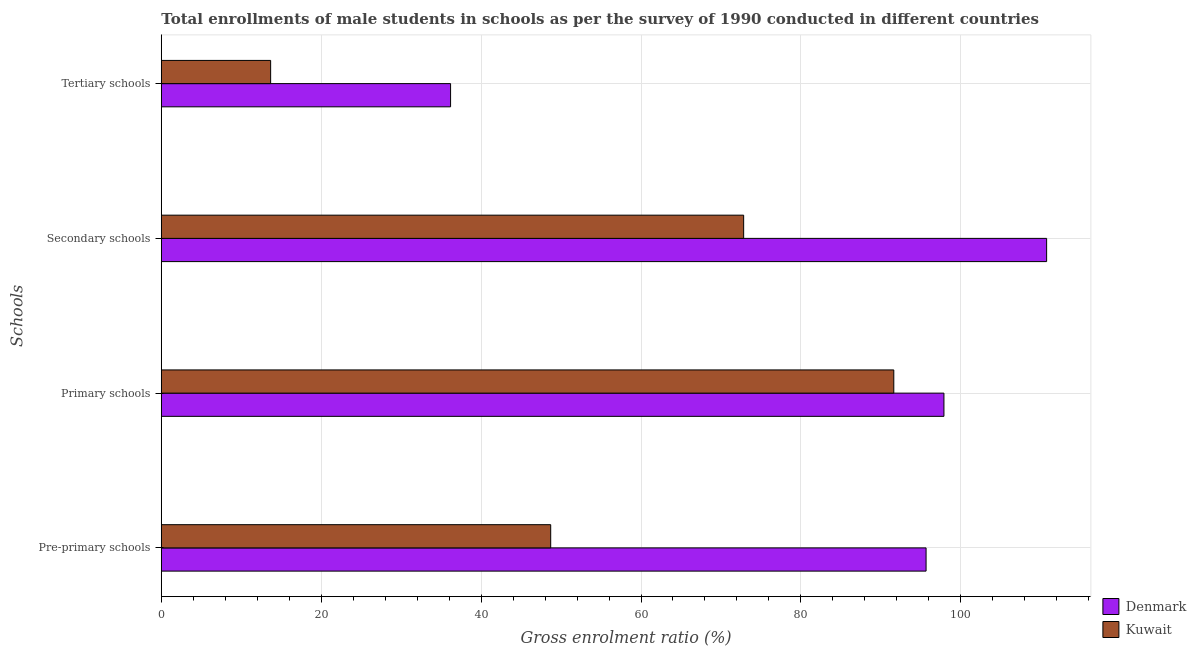How many groups of bars are there?
Give a very brief answer. 4. Are the number of bars per tick equal to the number of legend labels?
Your response must be concise. Yes. How many bars are there on the 2nd tick from the top?
Provide a short and direct response. 2. How many bars are there on the 1st tick from the bottom?
Ensure brevity in your answer.  2. What is the label of the 4th group of bars from the top?
Keep it short and to the point. Pre-primary schools. What is the gross enrolment ratio(male) in pre-primary schools in Kuwait?
Provide a succinct answer. 48.71. Across all countries, what is the maximum gross enrolment ratio(male) in pre-primary schools?
Your answer should be compact. 95.66. Across all countries, what is the minimum gross enrolment ratio(male) in tertiary schools?
Give a very brief answer. 13.67. In which country was the gross enrolment ratio(male) in secondary schools maximum?
Offer a terse response. Denmark. In which country was the gross enrolment ratio(male) in primary schools minimum?
Your answer should be compact. Kuwait. What is the total gross enrolment ratio(male) in primary schools in the graph?
Your answer should be very brief. 189.51. What is the difference between the gross enrolment ratio(male) in secondary schools in Denmark and that in Kuwait?
Offer a very short reply. 37.9. What is the difference between the gross enrolment ratio(male) in pre-primary schools in Denmark and the gross enrolment ratio(male) in secondary schools in Kuwait?
Keep it short and to the point. 22.82. What is the average gross enrolment ratio(male) in secondary schools per country?
Make the answer very short. 91.79. What is the difference between the gross enrolment ratio(male) in primary schools and gross enrolment ratio(male) in tertiary schools in Kuwait?
Your answer should be compact. 77.95. In how many countries, is the gross enrolment ratio(male) in primary schools greater than 36 %?
Offer a terse response. 2. What is the ratio of the gross enrolment ratio(male) in primary schools in Denmark to that in Kuwait?
Offer a terse response. 1.07. What is the difference between the highest and the second highest gross enrolment ratio(male) in tertiary schools?
Your answer should be compact. 22.51. What is the difference between the highest and the lowest gross enrolment ratio(male) in pre-primary schools?
Your answer should be compact. 46.95. Is the sum of the gross enrolment ratio(male) in tertiary schools in Denmark and Kuwait greater than the maximum gross enrolment ratio(male) in primary schools across all countries?
Provide a succinct answer. No. Is it the case that in every country, the sum of the gross enrolment ratio(male) in tertiary schools and gross enrolment ratio(male) in primary schools is greater than the sum of gross enrolment ratio(male) in secondary schools and gross enrolment ratio(male) in pre-primary schools?
Your answer should be very brief. Yes. What does the 1st bar from the top in Pre-primary schools represents?
Keep it short and to the point. Kuwait. Is it the case that in every country, the sum of the gross enrolment ratio(male) in pre-primary schools and gross enrolment ratio(male) in primary schools is greater than the gross enrolment ratio(male) in secondary schools?
Offer a terse response. Yes. Are all the bars in the graph horizontal?
Ensure brevity in your answer.  Yes. How many countries are there in the graph?
Provide a succinct answer. 2. What is the difference between two consecutive major ticks on the X-axis?
Give a very brief answer. 20. Are the values on the major ticks of X-axis written in scientific E-notation?
Offer a terse response. No. Does the graph contain any zero values?
Your response must be concise. No. Does the graph contain grids?
Keep it short and to the point. Yes. Where does the legend appear in the graph?
Provide a succinct answer. Bottom right. How many legend labels are there?
Your answer should be compact. 2. How are the legend labels stacked?
Provide a short and direct response. Vertical. What is the title of the graph?
Your answer should be very brief. Total enrollments of male students in schools as per the survey of 1990 conducted in different countries. What is the label or title of the Y-axis?
Provide a succinct answer. Schools. What is the Gross enrolment ratio (%) of Denmark in Pre-primary schools?
Keep it short and to the point. 95.66. What is the Gross enrolment ratio (%) of Kuwait in Pre-primary schools?
Your response must be concise. 48.71. What is the Gross enrolment ratio (%) in Denmark in Primary schools?
Make the answer very short. 97.89. What is the Gross enrolment ratio (%) of Kuwait in Primary schools?
Give a very brief answer. 91.62. What is the Gross enrolment ratio (%) in Denmark in Secondary schools?
Offer a terse response. 110.74. What is the Gross enrolment ratio (%) of Kuwait in Secondary schools?
Ensure brevity in your answer.  72.84. What is the Gross enrolment ratio (%) of Denmark in Tertiary schools?
Offer a terse response. 36.18. What is the Gross enrolment ratio (%) of Kuwait in Tertiary schools?
Ensure brevity in your answer.  13.67. Across all Schools, what is the maximum Gross enrolment ratio (%) in Denmark?
Give a very brief answer. 110.74. Across all Schools, what is the maximum Gross enrolment ratio (%) of Kuwait?
Ensure brevity in your answer.  91.62. Across all Schools, what is the minimum Gross enrolment ratio (%) of Denmark?
Offer a terse response. 36.18. Across all Schools, what is the minimum Gross enrolment ratio (%) in Kuwait?
Make the answer very short. 13.67. What is the total Gross enrolment ratio (%) in Denmark in the graph?
Your answer should be very brief. 340.47. What is the total Gross enrolment ratio (%) of Kuwait in the graph?
Your answer should be very brief. 226.84. What is the difference between the Gross enrolment ratio (%) in Denmark in Pre-primary schools and that in Primary schools?
Offer a terse response. -2.23. What is the difference between the Gross enrolment ratio (%) in Kuwait in Pre-primary schools and that in Primary schools?
Provide a short and direct response. -42.91. What is the difference between the Gross enrolment ratio (%) of Denmark in Pre-primary schools and that in Secondary schools?
Provide a short and direct response. -15.08. What is the difference between the Gross enrolment ratio (%) of Kuwait in Pre-primary schools and that in Secondary schools?
Keep it short and to the point. -24.13. What is the difference between the Gross enrolment ratio (%) of Denmark in Pre-primary schools and that in Tertiary schools?
Offer a terse response. 59.48. What is the difference between the Gross enrolment ratio (%) of Kuwait in Pre-primary schools and that in Tertiary schools?
Give a very brief answer. 35.03. What is the difference between the Gross enrolment ratio (%) in Denmark in Primary schools and that in Secondary schools?
Ensure brevity in your answer.  -12.84. What is the difference between the Gross enrolment ratio (%) in Kuwait in Primary schools and that in Secondary schools?
Your response must be concise. 18.78. What is the difference between the Gross enrolment ratio (%) in Denmark in Primary schools and that in Tertiary schools?
Make the answer very short. 61.71. What is the difference between the Gross enrolment ratio (%) of Kuwait in Primary schools and that in Tertiary schools?
Provide a succinct answer. 77.95. What is the difference between the Gross enrolment ratio (%) of Denmark in Secondary schools and that in Tertiary schools?
Your answer should be very brief. 74.55. What is the difference between the Gross enrolment ratio (%) in Kuwait in Secondary schools and that in Tertiary schools?
Make the answer very short. 59.16. What is the difference between the Gross enrolment ratio (%) of Denmark in Pre-primary schools and the Gross enrolment ratio (%) of Kuwait in Primary schools?
Your answer should be very brief. 4.04. What is the difference between the Gross enrolment ratio (%) in Denmark in Pre-primary schools and the Gross enrolment ratio (%) in Kuwait in Secondary schools?
Keep it short and to the point. 22.82. What is the difference between the Gross enrolment ratio (%) in Denmark in Pre-primary schools and the Gross enrolment ratio (%) in Kuwait in Tertiary schools?
Keep it short and to the point. 81.98. What is the difference between the Gross enrolment ratio (%) in Denmark in Primary schools and the Gross enrolment ratio (%) in Kuwait in Secondary schools?
Give a very brief answer. 25.05. What is the difference between the Gross enrolment ratio (%) of Denmark in Primary schools and the Gross enrolment ratio (%) of Kuwait in Tertiary schools?
Make the answer very short. 84.22. What is the difference between the Gross enrolment ratio (%) of Denmark in Secondary schools and the Gross enrolment ratio (%) of Kuwait in Tertiary schools?
Provide a succinct answer. 97.06. What is the average Gross enrolment ratio (%) of Denmark per Schools?
Offer a terse response. 85.12. What is the average Gross enrolment ratio (%) in Kuwait per Schools?
Offer a very short reply. 56.71. What is the difference between the Gross enrolment ratio (%) of Denmark and Gross enrolment ratio (%) of Kuwait in Pre-primary schools?
Provide a succinct answer. 46.95. What is the difference between the Gross enrolment ratio (%) of Denmark and Gross enrolment ratio (%) of Kuwait in Primary schools?
Offer a terse response. 6.27. What is the difference between the Gross enrolment ratio (%) of Denmark and Gross enrolment ratio (%) of Kuwait in Secondary schools?
Offer a very short reply. 37.9. What is the difference between the Gross enrolment ratio (%) in Denmark and Gross enrolment ratio (%) in Kuwait in Tertiary schools?
Keep it short and to the point. 22.51. What is the ratio of the Gross enrolment ratio (%) of Denmark in Pre-primary schools to that in Primary schools?
Make the answer very short. 0.98. What is the ratio of the Gross enrolment ratio (%) of Kuwait in Pre-primary schools to that in Primary schools?
Ensure brevity in your answer.  0.53. What is the ratio of the Gross enrolment ratio (%) of Denmark in Pre-primary schools to that in Secondary schools?
Keep it short and to the point. 0.86. What is the ratio of the Gross enrolment ratio (%) in Kuwait in Pre-primary schools to that in Secondary schools?
Offer a very short reply. 0.67. What is the ratio of the Gross enrolment ratio (%) in Denmark in Pre-primary schools to that in Tertiary schools?
Ensure brevity in your answer.  2.64. What is the ratio of the Gross enrolment ratio (%) in Kuwait in Pre-primary schools to that in Tertiary schools?
Your response must be concise. 3.56. What is the ratio of the Gross enrolment ratio (%) in Denmark in Primary schools to that in Secondary schools?
Provide a short and direct response. 0.88. What is the ratio of the Gross enrolment ratio (%) of Kuwait in Primary schools to that in Secondary schools?
Your answer should be very brief. 1.26. What is the ratio of the Gross enrolment ratio (%) of Denmark in Primary schools to that in Tertiary schools?
Offer a terse response. 2.71. What is the ratio of the Gross enrolment ratio (%) in Kuwait in Primary schools to that in Tertiary schools?
Make the answer very short. 6.7. What is the ratio of the Gross enrolment ratio (%) in Denmark in Secondary schools to that in Tertiary schools?
Provide a short and direct response. 3.06. What is the ratio of the Gross enrolment ratio (%) in Kuwait in Secondary schools to that in Tertiary schools?
Ensure brevity in your answer.  5.33. What is the difference between the highest and the second highest Gross enrolment ratio (%) of Denmark?
Keep it short and to the point. 12.84. What is the difference between the highest and the second highest Gross enrolment ratio (%) in Kuwait?
Offer a terse response. 18.78. What is the difference between the highest and the lowest Gross enrolment ratio (%) in Denmark?
Provide a succinct answer. 74.55. What is the difference between the highest and the lowest Gross enrolment ratio (%) of Kuwait?
Provide a succinct answer. 77.95. 